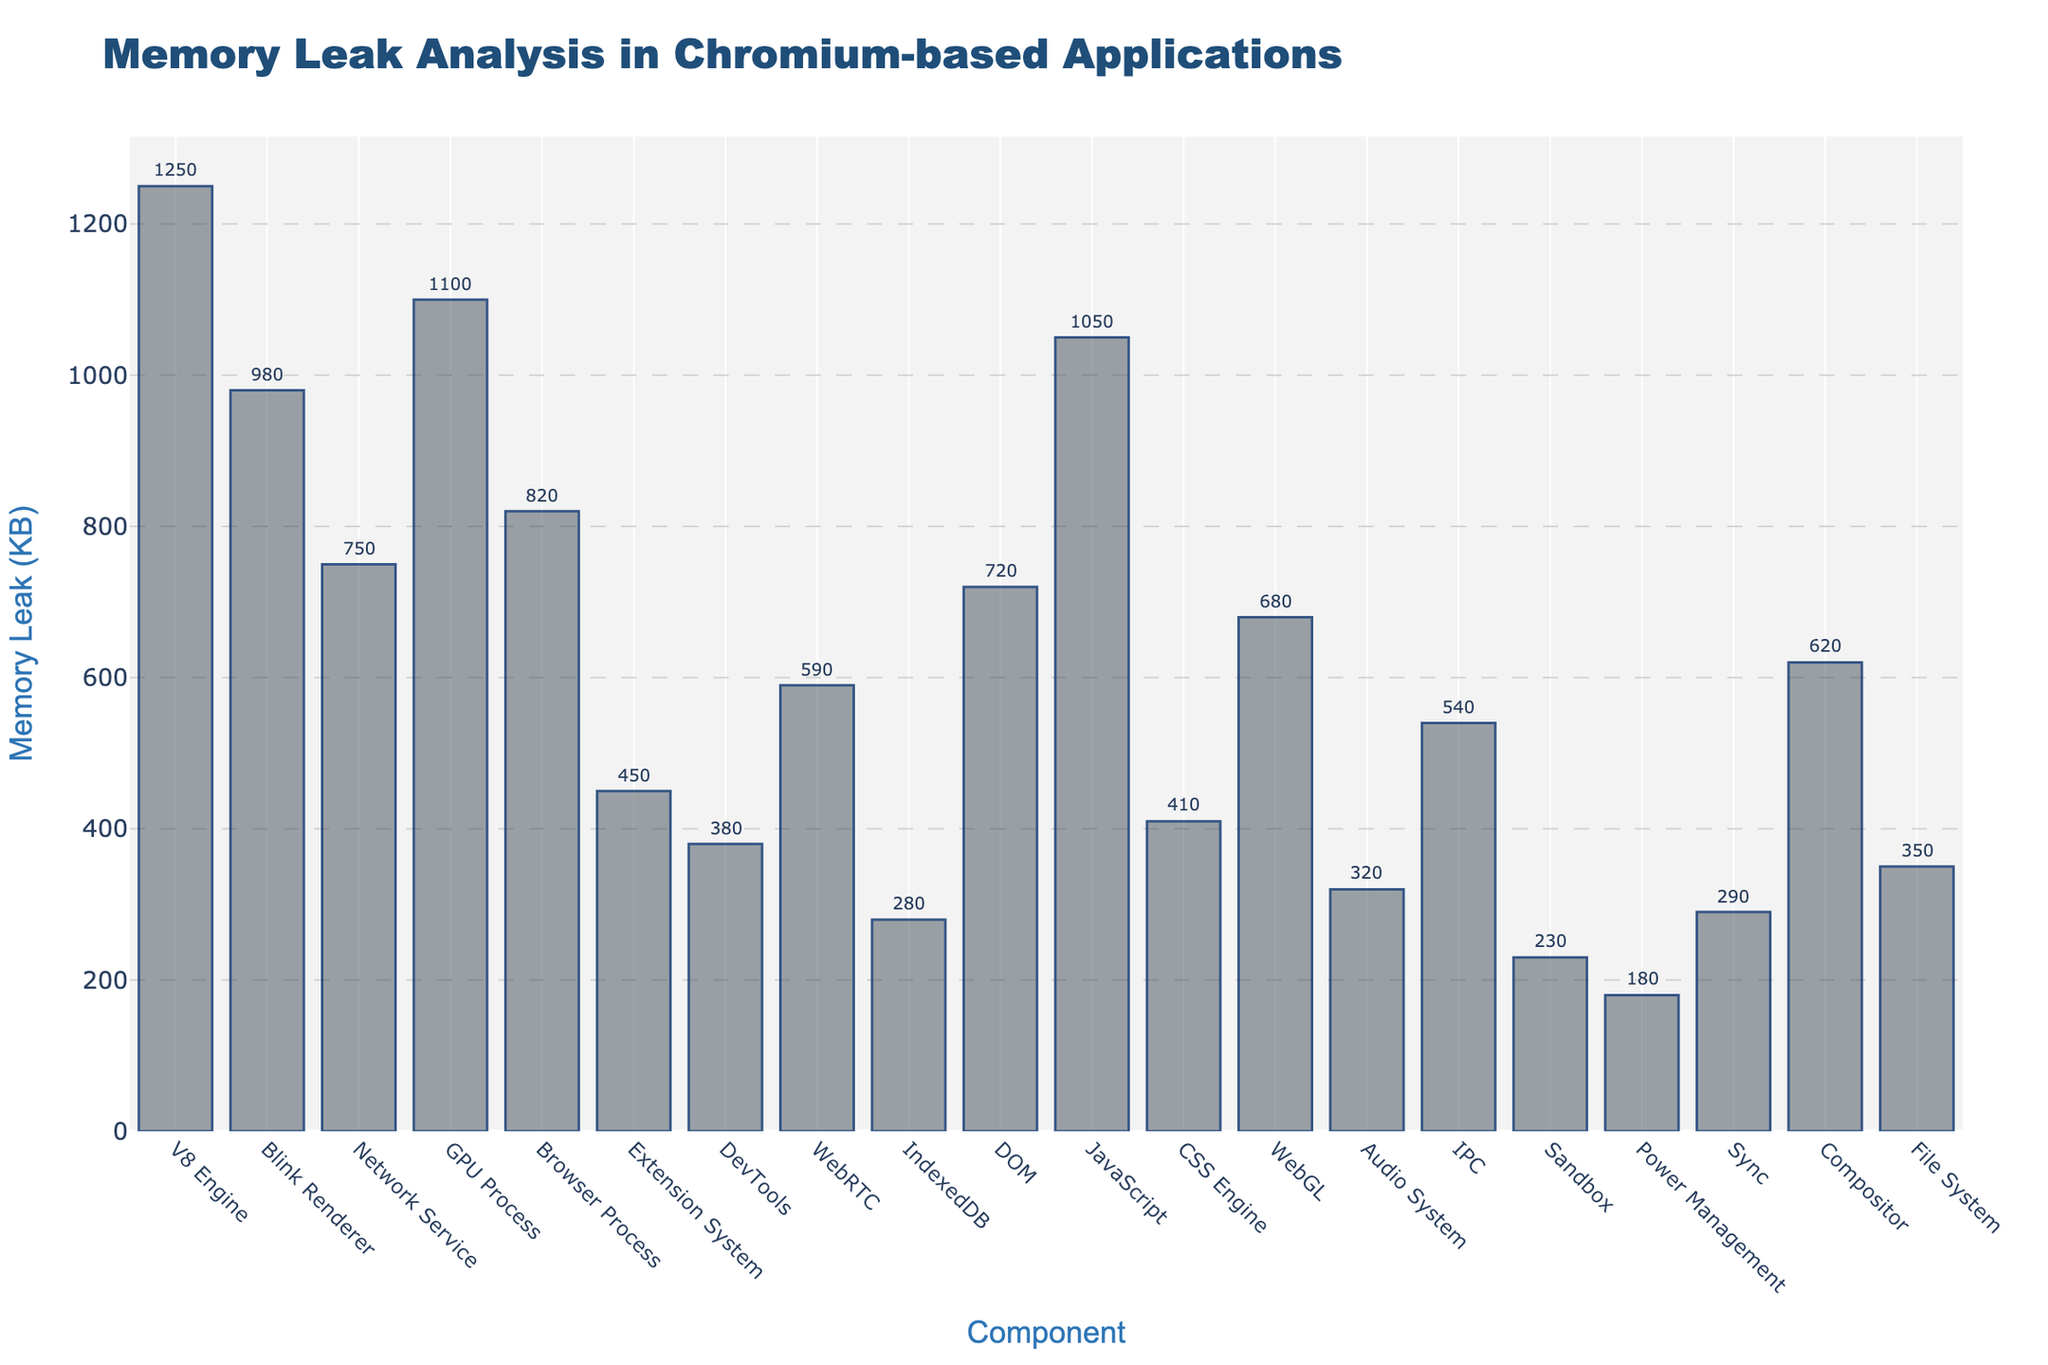What's the title of the figure? The title of the figure is displayed at the top of the plot
Answer: Memory Leak Analysis in Chromium-based Applications What's the y-axis title? The y-axis title is displayed on the left side of the plot
Answer: Memory Leak (KB) How many components are shown in the figure? Count the number of unique x-axis labels (components)
Answer: 20 Which component has the highest memory leak? Identify the tallest bar in the plot and check the corresponding x-axis label
Answer: V8 Engine What's the memory leak of the JavaScript component? Locate the JavaScript component on the x-axis and check the value indicated by its bar along the y-axis
Answer: 1050 KB What's the average memory leak across all components? Sum up all memory leak values and divide by the total number of components. (1250 + 980 + 750 + 1100 + 820 + 450 + 380 + 590 + 280 + 720 + 1050 + 410 + 680 + 320 + 540 + 230 + 180 + 290 + 620 + 350) / 20 = 11790 / 20 = 589.5
Answer: 589.5 KB Which component has the lowest memory leak? Identify the shortest bar in the plot and check the corresponding x-axis label
Answer: Power Management How much more memory leak does the V8 Engine have compared to the CSS Engine? Subtract the memory leak value of the CSS Engine from the memory leak value of the V8 Engine. 1250 - 410 = 840
Answer: 840 KB Are there more components with memory leaks greater than 1000 KB or less than 500 KB? Count components with memory leak values greater than 1000 KB and those with values less than 500 KB. Greater than 1000 KB: 4 (V8 Engine, GPU Process, JavaScript, Blink Renderer); Less than 500 KB: 7 (Extension System, DevTools, IndexedDB, CSS Engine, Audio System, Sandbox, Power Management).
Answer: Less than 500 KB What's the median memory leak value? Sort the values and find the middle value. For even number of values, take the average of the two middle values. Sorted values: [180, 230, 280, 290, 320, 350, 380, 410, 450, 540, 590, 620, 680, 720, 750, 820, 980, 1050, 1100, 1250]. Middle values: 540 and 590. (540 + 590) / 2 = 565
Answer: 565 KB 